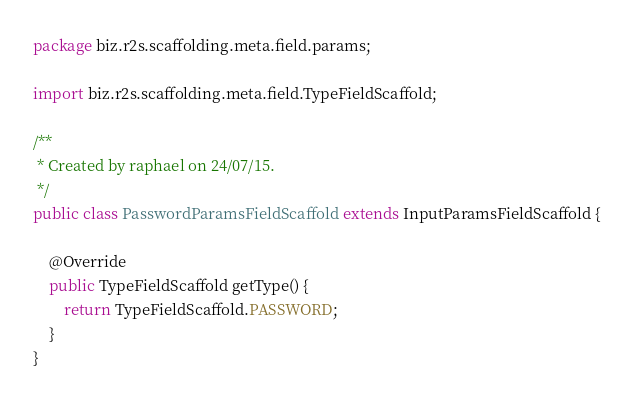<code> <loc_0><loc_0><loc_500><loc_500><_Java_>package biz.r2s.scaffolding.meta.field.params;

import biz.r2s.scaffolding.meta.field.TypeFieldScaffold;

/**
 * Created by raphael on 24/07/15.
 */
public class PasswordParamsFieldScaffold extends InputParamsFieldScaffold {

	@Override
	public TypeFieldScaffold getType() {
		return TypeFieldScaffold.PASSWORD;
	}
}
</code> 